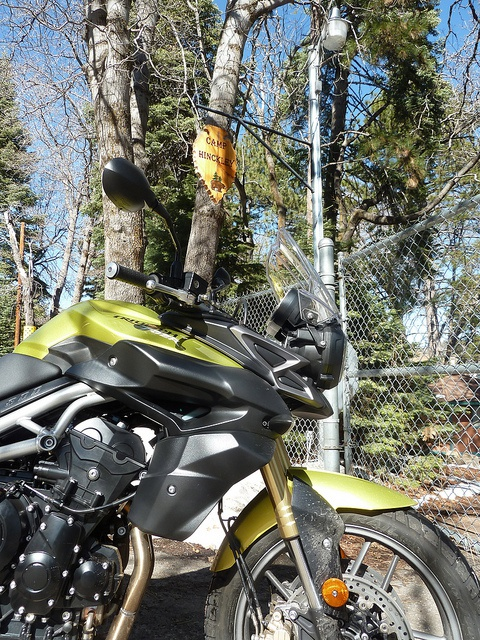Describe the objects in this image and their specific colors. I can see a motorcycle in lightblue, black, gray, darkgray, and white tones in this image. 